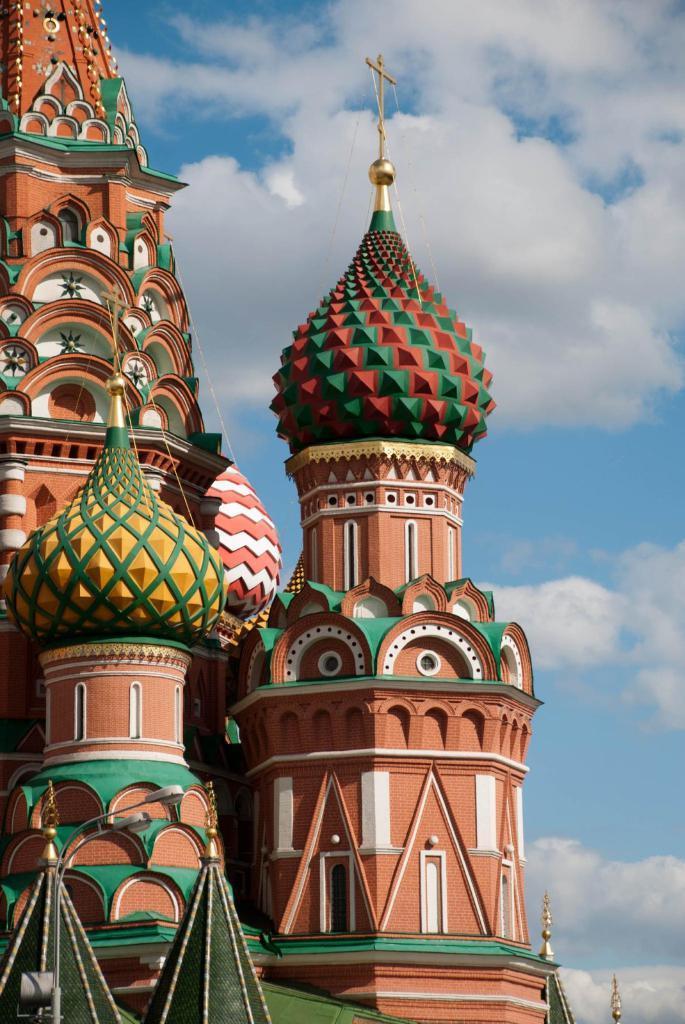Can you describe this image briefly? In this image I can see a building in the front. On the bottom left side of the image I can see a pole and two lights. In the background I can see clouds and the sky. 